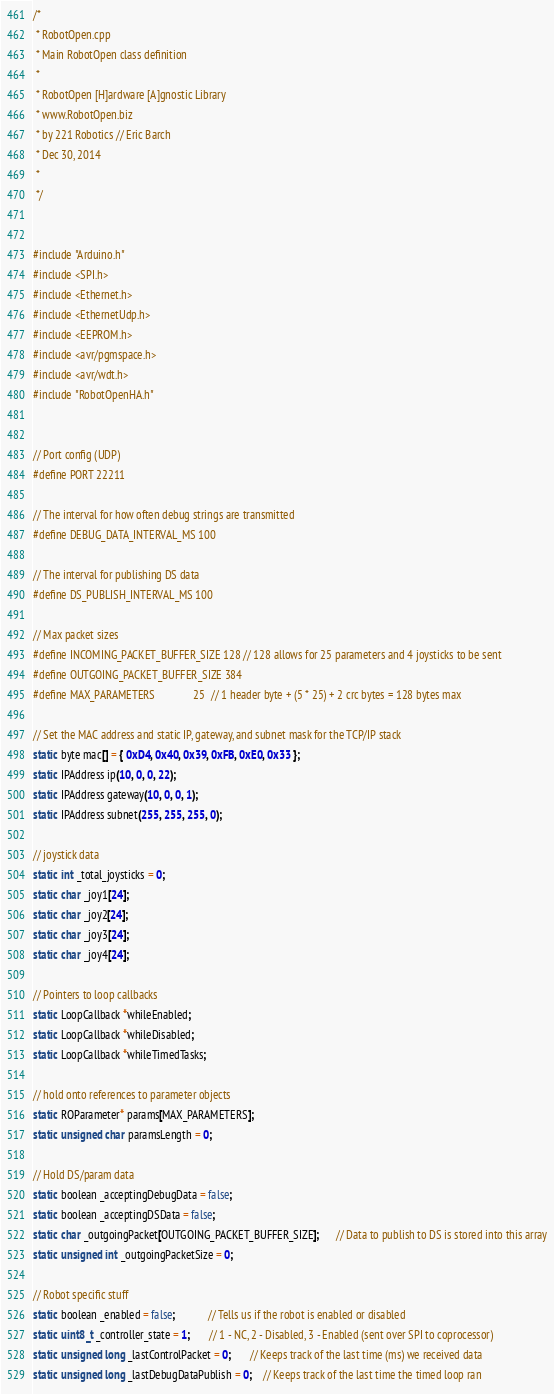Convert code to text. <code><loc_0><loc_0><loc_500><loc_500><_C++_>/*
 * RobotOpen.cpp
 * Main RobotOpen class definition
 * 
 * RobotOpen [H]ardware [A]gnostic Library
 * www.RobotOpen.biz
 * by 221 Robotics // Eric Barch
 * Dec 30, 2014
 * 
 */


#include "Arduino.h"
#include <SPI.h>
#include <Ethernet.h>
#include <EthernetUdp.h>
#include <EEPROM.h>
#include <avr/pgmspace.h>
#include <avr/wdt.h>
#include "RobotOpenHA.h"


// Port config (UDP)
#define PORT 22211

// The interval for how often debug strings are transmitted
#define DEBUG_DATA_INTERVAL_MS 100

// The interval for publishing DS data
#define DS_PUBLISH_INTERVAL_MS 100

// Max packet sizes
#define INCOMING_PACKET_BUFFER_SIZE 128 // 128 allows for 25 parameters and 4 joysticks to be sent
#define OUTGOING_PACKET_BUFFER_SIZE 384
#define MAX_PARAMETERS              25  // 1 header byte + (5 * 25) + 2 crc bytes = 128 bytes max

// Set the MAC address and static IP, gateway, and subnet mask for the TCP/IP stack
static byte mac[] = { 0xD4, 0x40, 0x39, 0xFB, 0xE0, 0x33 };
static IPAddress ip(10, 0, 0, 22);
static IPAddress gateway(10, 0, 0, 1);
static IPAddress subnet(255, 255, 255, 0);

// joystick data
static int _total_joysticks = 0;
static char _joy1[24];
static char _joy2[24];
static char _joy3[24];
static char _joy4[24];

// Pointers to loop callbacks
static LoopCallback *whileEnabled;
static LoopCallback *whileDisabled;
static LoopCallback *whileTimedTasks;

// hold onto references to parameter objects
static ROParameter* params[MAX_PARAMETERS];
static unsigned char paramsLength = 0;

// Hold DS/param data
static boolean _acceptingDebugData = false;
static boolean _acceptingDSData = false;
static char _outgoingPacket[OUTGOING_PACKET_BUFFER_SIZE];      // Data to publish to DS is stored into this array
static unsigned int _outgoingPacketSize = 0;

// Robot specific stuff
static boolean _enabled = false;            // Tells us if the robot is enabled or disabled
static uint8_t _controller_state = 1;       // 1 - NC, 2 - Disabled, 3 - Enabled (sent over SPI to coprocessor)
static unsigned long _lastControlPacket = 0;       // Keeps track of the last time (ms) we received data
static unsigned long _lastDebugDataPublish = 0;    // Keeps track of the last time the timed loop ran</code> 